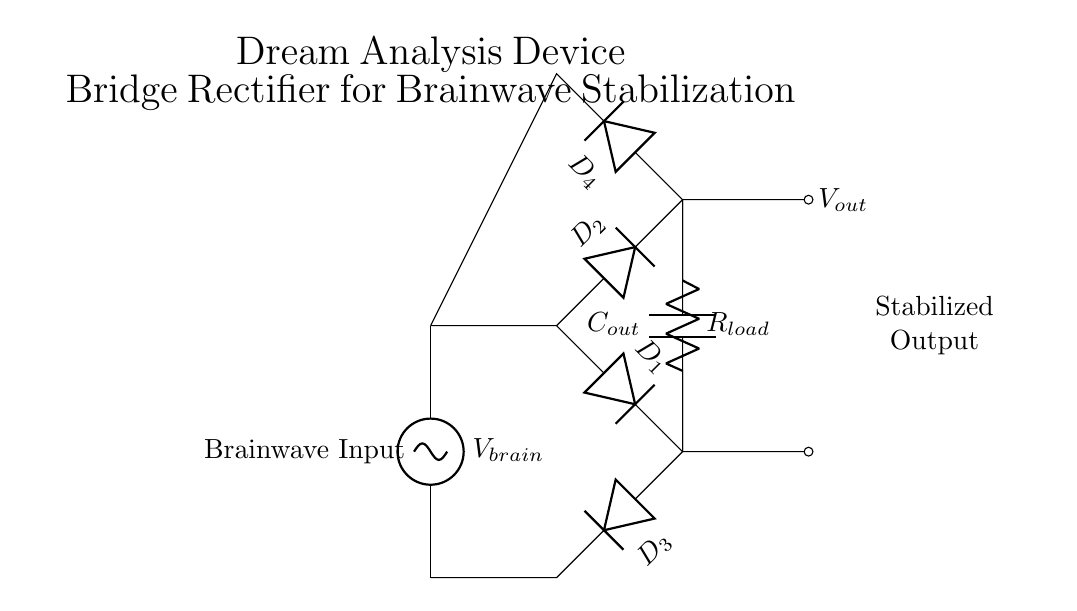What is the main function of the circuit? The main function is to stabilize brainwave signals by converting AC input to a DC output using the bridge rectifier configuration.
Answer: Stabilize brainwave signals How many diodes are used in this rectifier circuit? There are four diodes labeled D1, D2, D3, and D4 that form the bridge rectifier in the diagram.
Answer: Four diodes What is the output voltage symbol in the circuit? The output voltage is represented by the symbol Vout, which is indicated as the resultant voltage after rectification.
Answer: Vout What component is responsible for smoothing the output? The capacitor labeled Cout is responsible for smoothing the output by filtering the rectified signal from the diodes.
Answer: Cout How many terminals does the load resistor have? The load resistor labeled Rload has two terminals, which connect to the output of the rectifier to provide the load for the stabilized signal.
Answer: Two terminals What type of signal does the circuit accept as input? The circuit accepts an AC signal, indicated by the source labeled Vbrain connected at the input side of the bridge rectifier.
Answer: AC signal What is the purpose of the load resistor in the circuit? The load resistor Rload is used to absorb the power from the stabilized output voltage and provide a load for the circuit operation.
Answer: Absorb power 